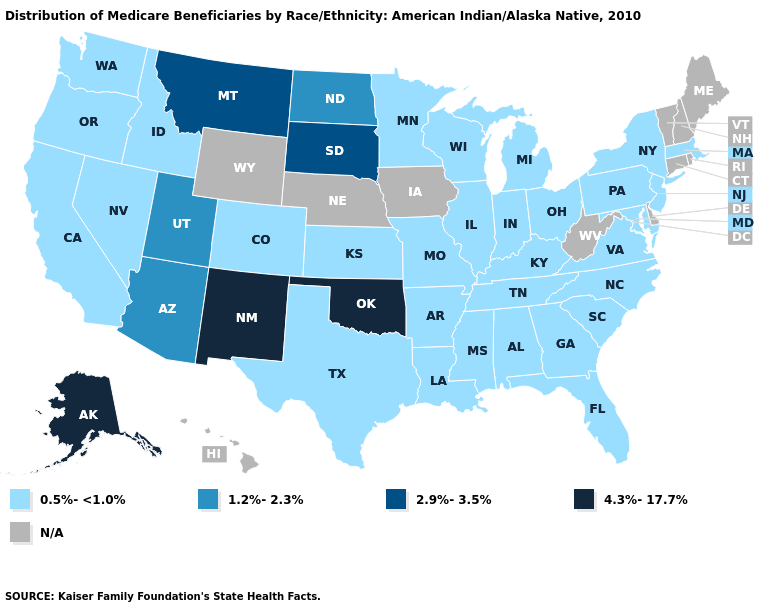Does New Mexico have the highest value in the West?
Be succinct. Yes. What is the value of Idaho?
Be succinct. 0.5%-<1.0%. Name the states that have a value in the range 4.3%-17.7%?
Write a very short answer. Alaska, New Mexico, Oklahoma. What is the lowest value in the MidWest?
Answer briefly. 0.5%-<1.0%. Name the states that have a value in the range 4.3%-17.7%?
Give a very brief answer. Alaska, New Mexico, Oklahoma. Does the first symbol in the legend represent the smallest category?
Write a very short answer. Yes. Among the states that border South Dakota , which have the lowest value?
Be succinct. Minnesota. Does the map have missing data?
Quick response, please. Yes. What is the value of Ohio?
Give a very brief answer. 0.5%-<1.0%. Which states have the highest value in the USA?
Keep it brief. Alaska, New Mexico, Oklahoma. Name the states that have a value in the range 0.5%-<1.0%?
Quick response, please. Alabama, Arkansas, California, Colorado, Florida, Georgia, Idaho, Illinois, Indiana, Kansas, Kentucky, Louisiana, Maryland, Massachusetts, Michigan, Minnesota, Mississippi, Missouri, Nevada, New Jersey, New York, North Carolina, Ohio, Oregon, Pennsylvania, South Carolina, Tennessee, Texas, Virginia, Washington, Wisconsin. What is the value of Ohio?
Be succinct. 0.5%-<1.0%. Which states hav the highest value in the West?
Concise answer only. Alaska, New Mexico. Does Montana have the lowest value in the USA?
Keep it brief. No. Name the states that have a value in the range 0.5%-<1.0%?
Short answer required. Alabama, Arkansas, California, Colorado, Florida, Georgia, Idaho, Illinois, Indiana, Kansas, Kentucky, Louisiana, Maryland, Massachusetts, Michigan, Minnesota, Mississippi, Missouri, Nevada, New Jersey, New York, North Carolina, Ohio, Oregon, Pennsylvania, South Carolina, Tennessee, Texas, Virginia, Washington, Wisconsin. 